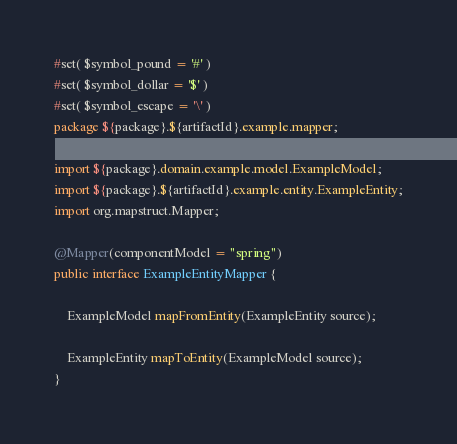Convert code to text. <code><loc_0><loc_0><loc_500><loc_500><_Java_>#set( $symbol_pound = '#' )
#set( $symbol_dollar = '$' )
#set( $symbol_escape = '\' )
package ${package}.${artifactId}.example.mapper;

import ${package}.domain.example.model.ExampleModel;
import ${package}.${artifactId}.example.entity.ExampleEntity;
import org.mapstruct.Mapper;

@Mapper(componentModel = "spring")
public interface ExampleEntityMapper {

    ExampleModel mapFromEntity(ExampleEntity source);

    ExampleEntity mapToEntity(ExampleModel source);
}
</code> 